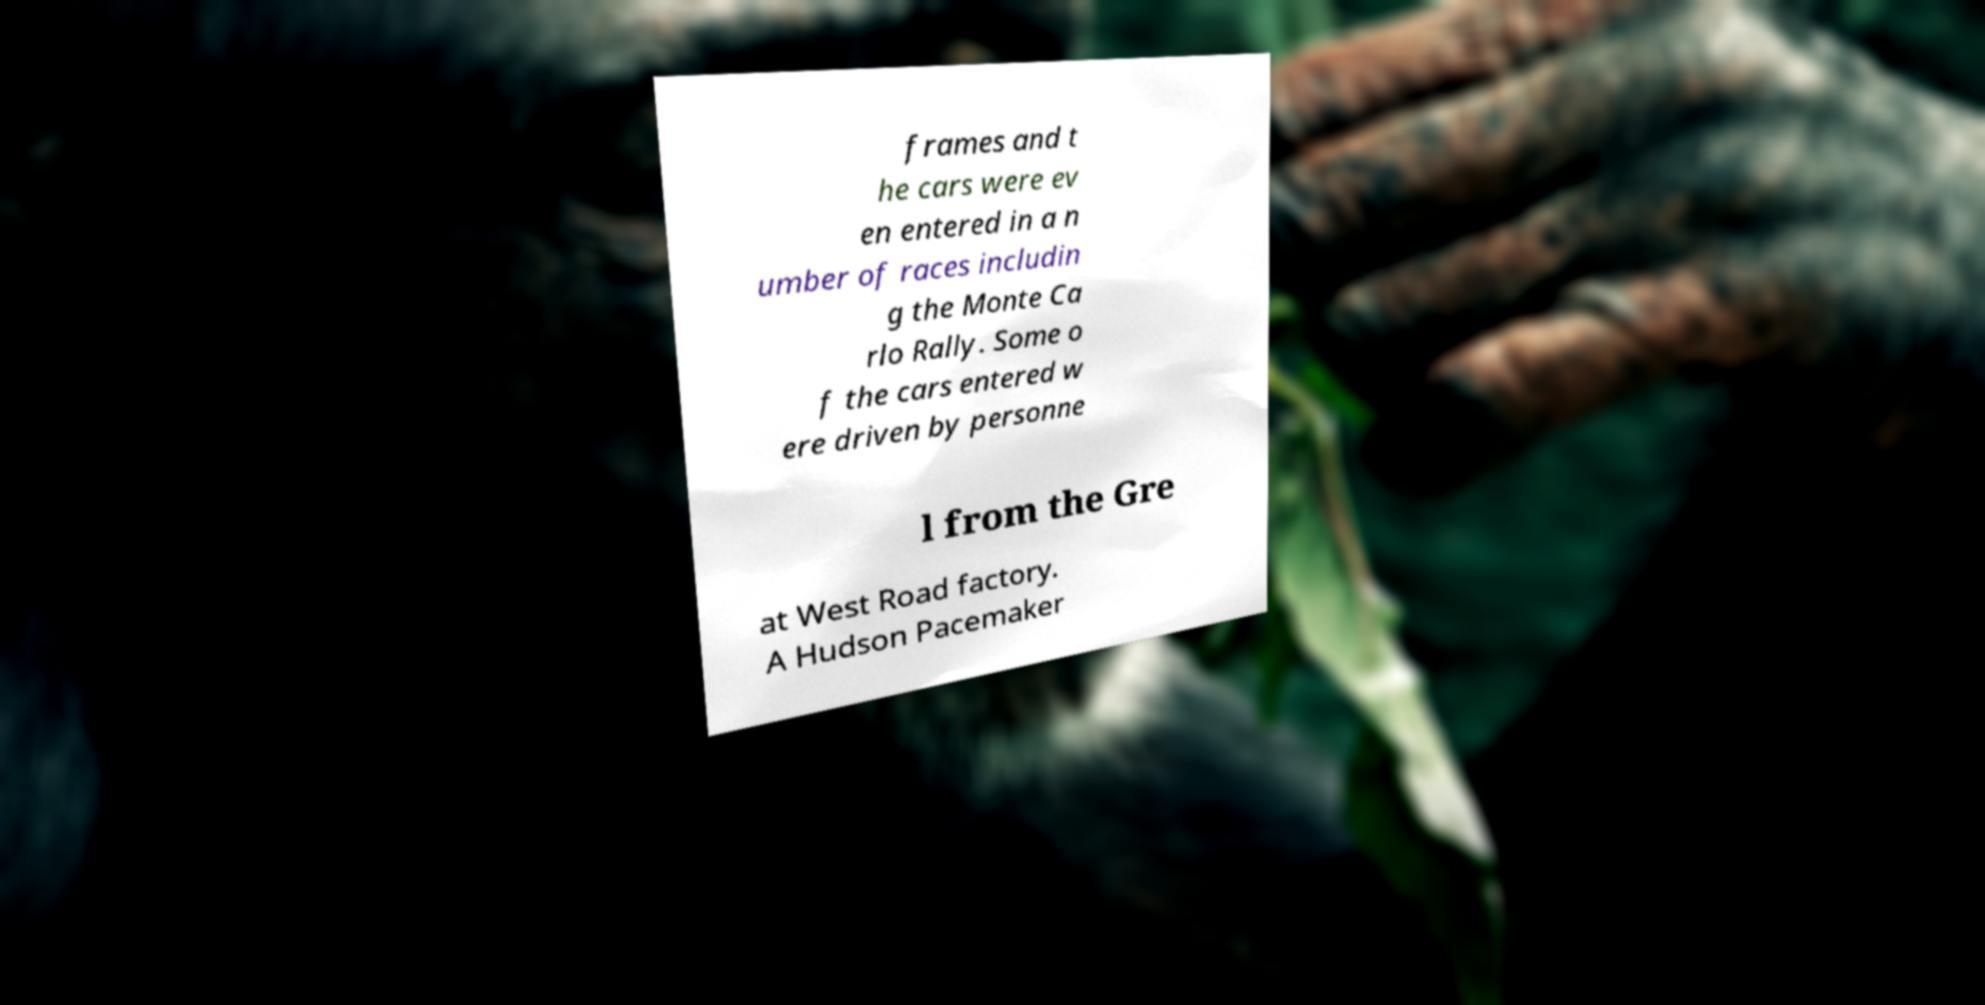Could you extract and type out the text from this image? frames and t he cars were ev en entered in a n umber of races includin g the Monte Ca rlo Rally. Some o f the cars entered w ere driven by personne l from the Gre at West Road factory. A Hudson Pacemaker 